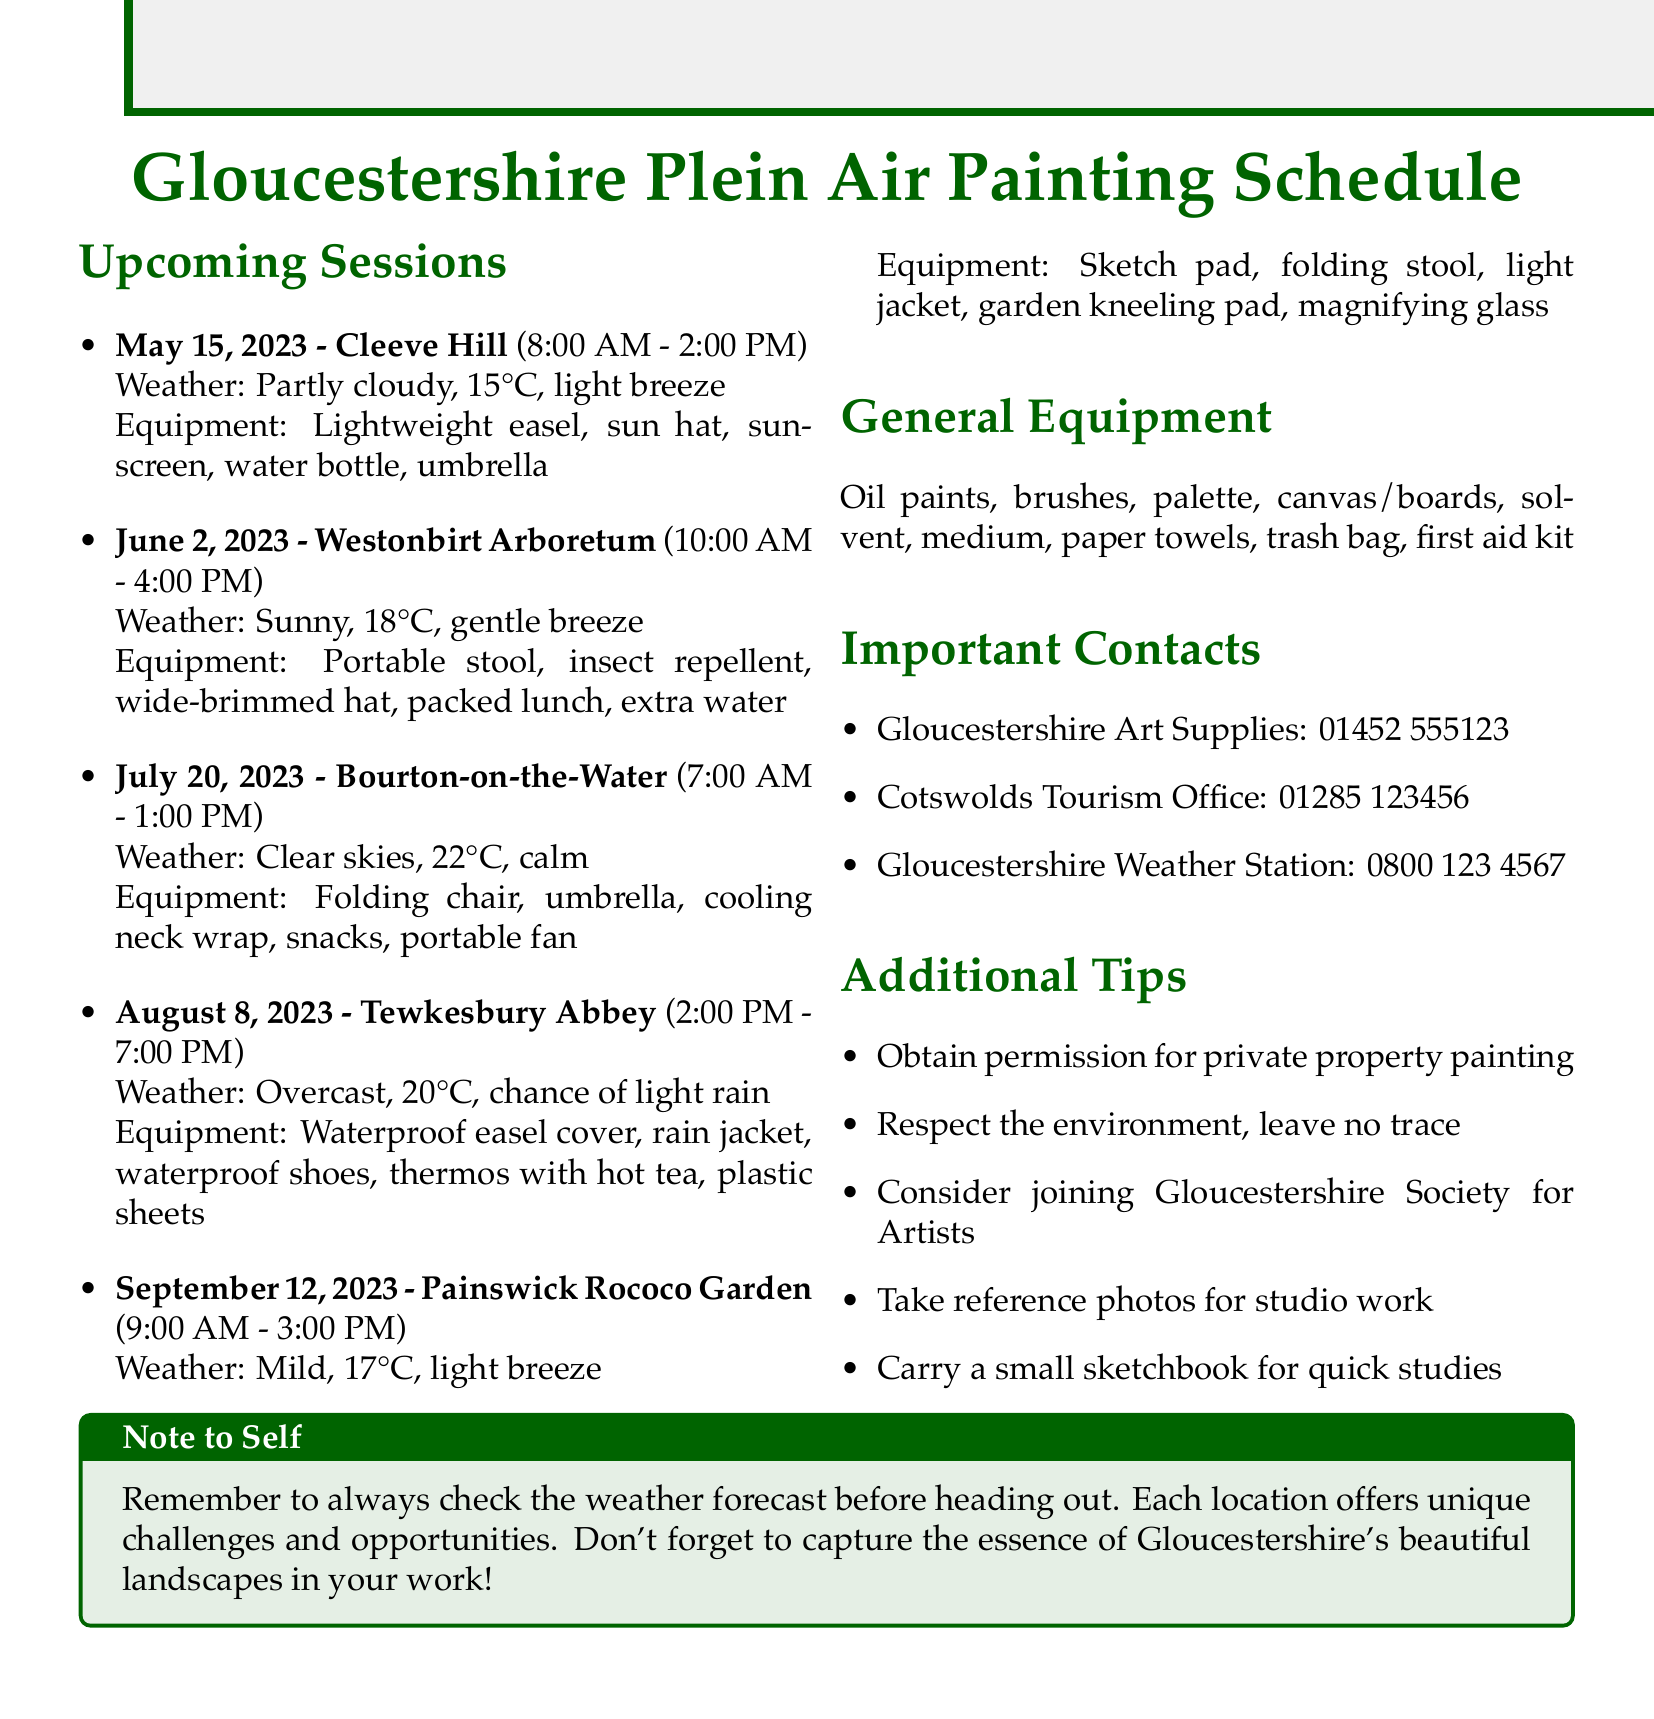What is the date for the session at Cleeve Hill? The date for the Cleeve Hill session is listed in the document.
Answer: May 15, 2023 What is the weather forecast for Tewkesbury Abbey on August 8, 2023? The document specifies the weather forecast for each location, including Tewkesbury Abbey.
Answer: Overcast, 20°C, chance of light rain What equipment should be brought to Painswick Rococo Garden? The document lists specific equipment suggested for each session, including Painswick Rococo Garden.
Answer: Sketch pad, folding stool, light jacket, garden kneeling pad, magnifying glass What time does the session at Westonbirt Arboretum begin? The session times are clearly stated for each location, including Westonbirt Arboretum.
Answer: 10:00 AM How many plein air painting sessions are scheduled in total? The total number of sessions can be counted from the schedule section of the document.
Answer: 5 Which contact is for last-minute art supply needs? The important contacts section provides names and purposes; the appropriate contact for art supplies can be identified.
Answer: Gloucestershire Art Supplies What is a suggested tip regarding private property? The additional tips section contains guidance for painters, including regarding private property.
Answer: Obtain permission for private property painting What location is suggested for painting on July 20, 2023? Each session lists a specific location; the one for July 20, 2023, can be found in the document.
Answer: Bourton-on-the-Water 